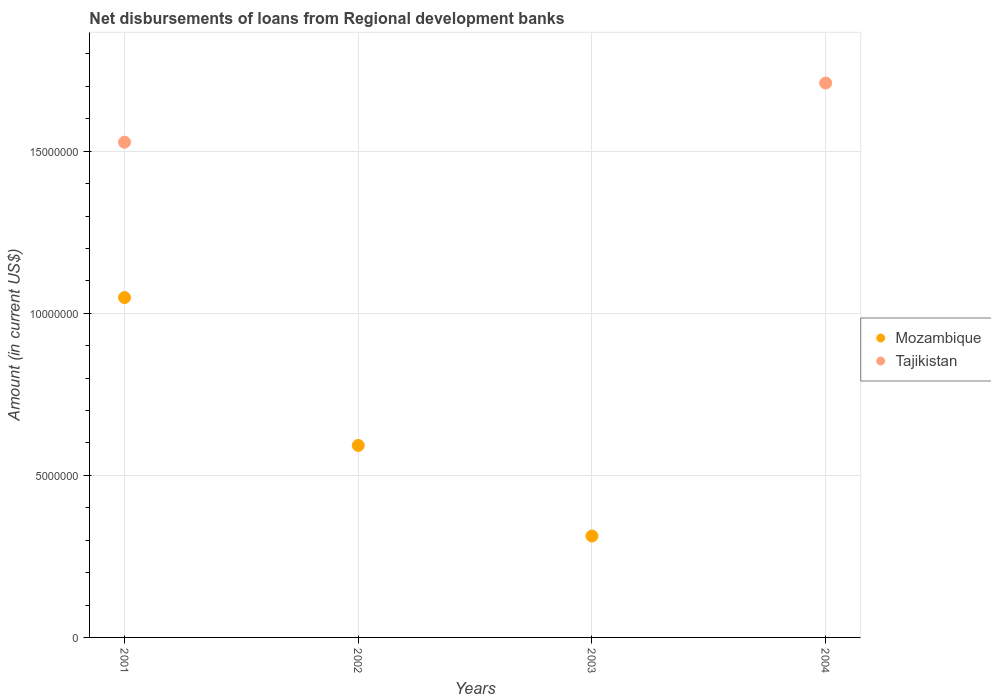How many different coloured dotlines are there?
Provide a short and direct response. 2. What is the amount of disbursements of loans from regional development banks in Tajikistan in 2001?
Keep it short and to the point. 1.53e+07. Across all years, what is the maximum amount of disbursements of loans from regional development banks in Tajikistan?
Your answer should be compact. 1.71e+07. In which year was the amount of disbursements of loans from regional development banks in Mozambique maximum?
Your response must be concise. 2001. What is the total amount of disbursements of loans from regional development banks in Mozambique in the graph?
Make the answer very short. 1.95e+07. What is the difference between the amount of disbursements of loans from regional development banks in Tajikistan in 2001 and that in 2004?
Your answer should be compact. -1.82e+06. What is the difference between the amount of disbursements of loans from regional development banks in Mozambique in 2003 and the amount of disbursements of loans from regional development banks in Tajikistan in 2001?
Ensure brevity in your answer.  -1.21e+07. What is the average amount of disbursements of loans from regional development banks in Mozambique per year?
Offer a terse response. 4.88e+06. In the year 2001, what is the difference between the amount of disbursements of loans from regional development banks in Tajikistan and amount of disbursements of loans from regional development banks in Mozambique?
Your response must be concise. 4.79e+06. What is the ratio of the amount of disbursements of loans from regional development banks in Mozambique in 2001 to that in 2002?
Your answer should be compact. 1.77. Is the amount of disbursements of loans from regional development banks in Mozambique in 2002 less than that in 2003?
Provide a succinct answer. No. What is the difference between the highest and the second highest amount of disbursements of loans from regional development banks in Mozambique?
Offer a very short reply. 4.56e+06. What is the difference between the highest and the lowest amount of disbursements of loans from regional development banks in Tajikistan?
Your response must be concise. 1.71e+07. Is the sum of the amount of disbursements of loans from regional development banks in Mozambique in 2001 and 2002 greater than the maximum amount of disbursements of loans from regional development banks in Tajikistan across all years?
Give a very brief answer. No. How many dotlines are there?
Offer a very short reply. 2. How many years are there in the graph?
Offer a very short reply. 4. What is the difference between two consecutive major ticks on the Y-axis?
Provide a succinct answer. 5.00e+06. Are the values on the major ticks of Y-axis written in scientific E-notation?
Keep it short and to the point. No. Does the graph contain any zero values?
Your answer should be compact. Yes. Where does the legend appear in the graph?
Your response must be concise. Center right. How many legend labels are there?
Make the answer very short. 2. What is the title of the graph?
Ensure brevity in your answer.  Net disbursements of loans from Regional development banks. What is the label or title of the Y-axis?
Give a very brief answer. Amount (in current US$). What is the Amount (in current US$) of Mozambique in 2001?
Make the answer very short. 1.05e+07. What is the Amount (in current US$) of Tajikistan in 2001?
Provide a short and direct response. 1.53e+07. What is the Amount (in current US$) of Mozambique in 2002?
Keep it short and to the point. 5.92e+06. What is the Amount (in current US$) in Mozambique in 2003?
Ensure brevity in your answer.  3.13e+06. What is the Amount (in current US$) in Tajikistan in 2003?
Your answer should be very brief. 0. What is the Amount (in current US$) of Tajikistan in 2004?
Offer a very short reply. 1.71e+07. Across all years, what is the maximum Amount (in current US$) in Mozambique?
Give a very brief answer. 1.05e+07. Across all years, what is the maximum Amount (in current US$) in Tajikistan?
Provide a short and direct response. 1.71e+07. Across all years, what is the minimum Amount (in current US$) of Mozambique?
Offer a terse response. 0. What is the total Amount (in current US$) in Mozambique in the graph?
Your answer should be compact. 1.95e+07. What is the total Amount (in current US$) in Tajikistan in the graph?
Ensure brevity in your answer.  3.24e+07. What is the difference between the Amount (in current US$) in Mozambique in 2001 and that in 2002?
Offer a very short reply. 4.56e+06. What is the difference between the Amount (in current US$) in Mozambique in 2001 and that in 2003?
Ensure brevity in your answer.  7.36e+06. What is the difference between the Amount (in current US$) in Tajikistan in 2001 and that in 2004?
Your answer should be very brief. -1.82e+06. What is the difference between the Amount (in current US$) of Mozambique in 2002 and that in 2003?
Ensure brevity in your answer.  2.79e+06. What is the difference between the Amount (in current US$) of Mozambique in 2001 and the Amount (in current US$) of Tajikistan in 2004?
Give a very brief answer. -6.62e+06. What is the difference between the Amount (in current US$) in Mozambique in 2002 and the Amount (in current US$) in Tajikistan in 2004?
Your response must be concise. -1.12e+07. What is the difference between the Amount (in current US$) of Mozambique in 2003 and the Amount (in current US$) of Tajikistan in 2004?
Make the answer very short. -1.40e+07. What is the average Amount (in current US$) of Mozambique per year?
Provide a succinct answer. 4.88e+06. What is the average Amount (in current US$) in Tajikistan per year?
Make the answer very short. 8.09e+06. In the year 2001, what is the difference between the Amount (in current US$) of Mozambique and Amount (in current US$) of Tajikistan?
Give a very brief answer. -4.79e+06. What is the ratio of the Amount (in current US$) in Mozambique in 2001 to that in 2002?
Your response must be concise. 1.77. What is the ratio of the Amount (in current US$) of Mozambique in 2001 to that in 2003?
Provide a succinct answer. 3.35. What is the ratio of the Amount (in current US$) in Tajikistan in 2001 to that in 2004?
Provide a succinct answer. 0.89. What is the ratio of the Amount (in current US$) of Mozambique in 2002 to that in 2003?
Offer a terse response. 1.89. What is the difference between the highest and the second highest Amount (in current US$) of Mozambique?
Your answer should be very brief. 4.56e+06. What is the difference between the highest and the lowest Amount (in current US$) of Mozambique?
Provide a succinct answer. 1.05e+07. What is the difference between the highest and the lowest Amount (in current US$) of Tajikistan?
Provide a short and direct response. 1.71e+07. 